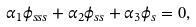<formula> <loc_0><loc_0><loc_500><loc_500>\alpha _ { 1 } \phi _ { s s s } + \alpha _ { 2 } \phi _ { s s } + \alpha _ { 3 } \phi _ { s } = 0 ,</formula> 